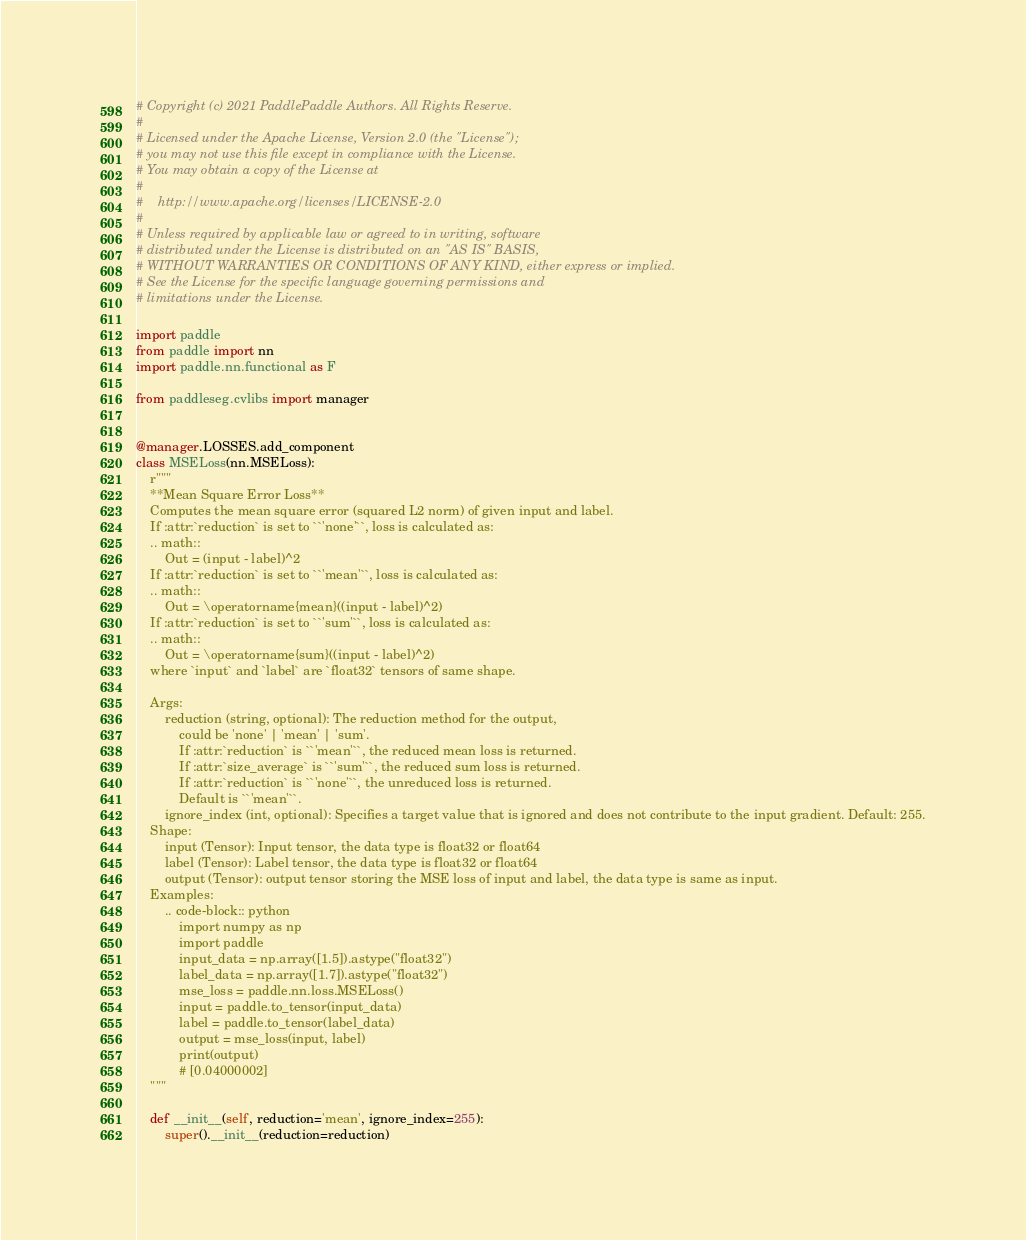<code> <loc_0><loc_0><loc_500><loc_500><_Python_># Copyright (c) 2021 PaddlePaddle Authors. All Rights Reserve.
#
# Licensed under the Apache License, Version 2.0 (the "License");
# you may not use this file except in compliance with the License.
# You may obtain a copy of the License at
#
#    http://www.apache.org/licenses/LICENSE-2.0
#
# Unless required by applicable law or agreed to in writing, software
# distributed under the License is distributed on an "AS IS" BASIS,
# WITHOUT WARRANTIES OR CONDITIONS OF ANY KIND, either express or implied.
# See the License for the specific language governing permissions and
# limitations under the License.

import paddle
from paddle import nn
import paddle.nn.functional as F

from paddleseg.cvlibs import manager


@manager.LOSSES.add_component
class MSELoss(nn.MSELoss):
    r"""
    **Mean Square Error Loss**
    Computes the mean square error (squared L2 norm) of given input and label.
    If :attr:`reduction` is set to ``'none'``, loss is calculated as:
    .. math::
        Out = (input - label)^2
    If :attr:`reduction` is set to ``'mean'``, loss is calculated as:
    .. math::
        Out = \operatorname{mean}((input - label)^2)
    If :attr:`reduction` is set to ``'sum'``, loss is calculated as:
    .. math::
        Out = \operatorname{sum}((input - label)^2)
    where `input` and `label` are `float32` tensors of same shape.

    Args:
        reduction (string, optional): The reduction method for the output,
            could be 'none' | 'mean' | 'sum'.
            If :attr:`reduction` is ``'mean'``, the reduced mean loss is returned.
            If :attr:`size_average` is ``'sum'``, the reduced sum loss is returned.
            If :attr:`reduction` is ``'none'``, the unreduced loss is returned.
            Default is ``'mean'``.
        ignore_index (int, optional): Specifies a target value that is ignored and does not contribute to the input gradient. Default: 255.
    Shape:
        input (Tensor): Input tensor, the data type is float32 or float64
        label (Tensor): Label tensor, the data type is float32 or float64
        output (Tensor): output tensor storing the MSE loss of input and label, the data type is same as input.
    Examples:
        .. code-block:: python
            import numpy as np
            import paddle
            input_data = np.array([1.5]).astype("float32")
            label_data = np.array([1.7]).astype("float32")
            mse_loss = paddle.nn.loss.MSELoss()
            input = paddle.to_tensor(input_data)
            label = paddle.to_tensor(label_data)
            output = mse_loss(input, label)
            print(output)
            # [0.04000002]
    """

    def __init__(self, reduction='mean', ignore_index=255):
        super().__init__(reduction=reduction)
</code> 